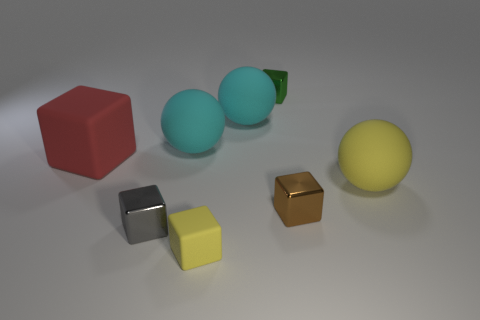What size is the green thing that is the same shape as the tiny gray metallic object?
Offer a very short reply. Small. Do the big rubber block and the tiny matte object have the same color?
Your answer should be compact. No. Is there any other thing that has the same shape as the big yellow object?
Provide a short and direct response. Yes. Are there any brown things that are behind the metal thing behind the large red matte cube?
Your answer should be compact. No. There is another large matte thing that is the same shape as the gray object; what color is it?
Your response must be concise. Red. What number of big matte balls have the same color as the tiny matte object?
Provide a short and direct response. 1. What is the color of the sphere that is to the left of the cyan matte object that is on the right side of the yellow thing that is in front of the gray metallic cube?
Your answer should be compact. Cyan. Is the gray cube made of the same material as the yellow block?
Your response must be concise. No. Is the red rubber thing the same shape as the gray metallic thing?
Make the answer very short. Yes. Are there the same number of spheres to the right of the yellow matte block and large red cubes left of the large rubber block?
Your answer should be compact. No. 